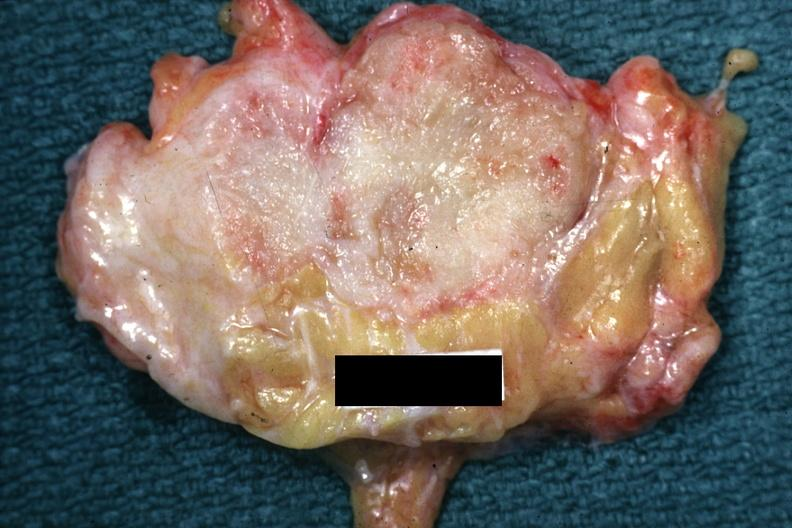s retroperitoneal leiomyosarcoma present?
Answer the question using a single word or phrase. No 